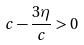Convert formula to latex. <formula><loc_0><loc_0><loc_500><loc_500>c - \frac { 3 \eta } { c } > 0</formula> 